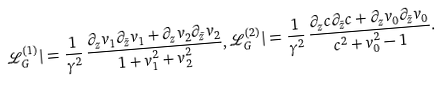Convert formula to latex. <formula><loc_0><loc_0><loc_500><loc_500>{ \mathcal { L } } _ { G } ^ { ( 1 ) } | = \frac { 1 } { \gamma ^ { 2 } } \, \frac { \partial _ { z } v _ { 1 } \partial _ { \bar { z } } v _ { 1 } + \partial _ { z } v _ { 2 } \partial _ { \bar { z } } v _ { 2 } } { 1 + v _ { 1 } ^ { 2 } + v _ { 2 } ^ { 2 } } , { \mathcal { L } } _ { G } ^ { ( 2 ) } | = \frac { 1 } { \gamma ^ { 2 } } \, \frac { \partial _ { z } c \partial _ { \bar { z } } c + \partial _ { z } v _ { 0 } \partial _ { \bar { z } } v _ { 0 } } { c ^ { 2 } + v _ { 0 } ^ { 2 } - 1 } .</formula> 